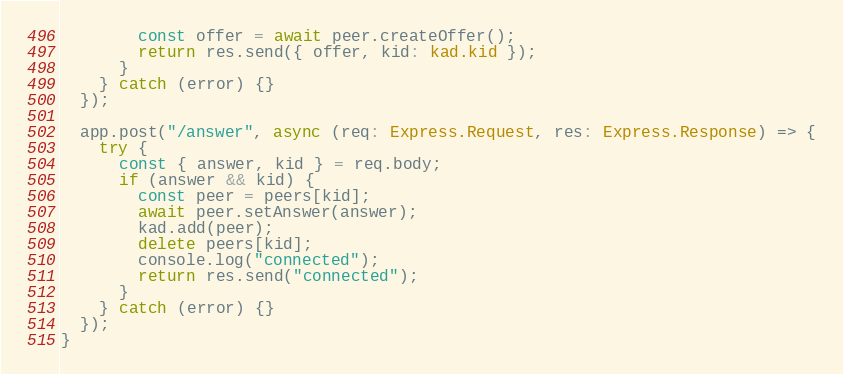<code> <loc_0><loc_0><loc_500><loc_500><_TypeScript_>        const offer = await peer.createOffer();
        return res.send({ offer, kid: kad.kid });
      }
    } catch (error) {}
  });

  app.post("/answer", async (req: Express.Request, res: Express.Response) => {
    try {
      const { answer, kid } = req.body;
      if (answer && kid) {
        const peer = peers[kid];
        await peer.setAnswer(answer);
        kad.add(peer);
        delete peers[kid];
        console.log("connected");
        return res.send("connected");
      }
    } catch (error) {}
  });
}
</code> 